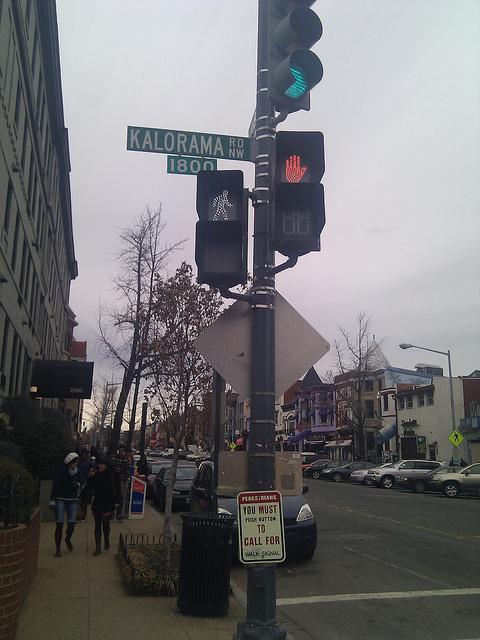How many people are in the picture?
Give a very brief answer. 2. How many traffic lights are in the picture?
Give a very brief answer. 3. How many big orange are there in the image ?
Give a very brief answer. 0. 